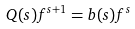Convert formula to latex. <formula><loc_0><loc_0><loc_500><loc_500>Q ( s ) f ^ { s + 1 } = b ( s ) f ^ { s }</formula> 